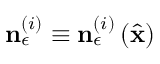Convert formula to latex. <formula><loc_0><loc_0><loc_500><loc_500>n _ { \epsilon } ^ { \left ( i \right ) } \equiv n _ { \epsilon } ^ { \left ( i \right ) } \left ( \hat { x } \right )</formula> 